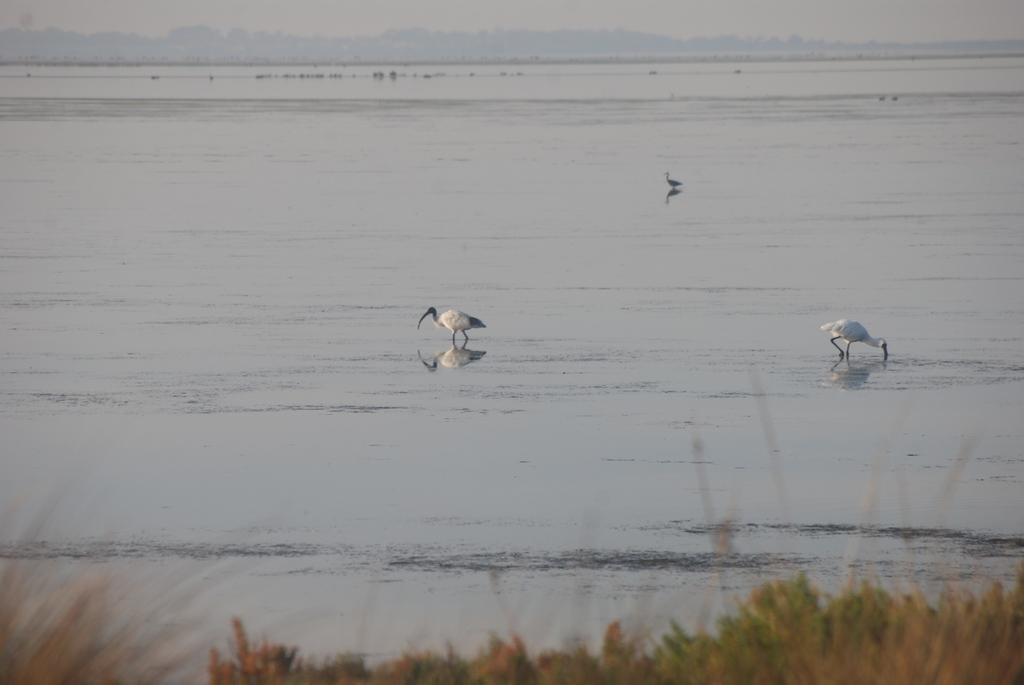What is located in the front of the image? There are plants in the front of the image. What are the birds doing in the image? The birds are standing in the water in the image. What is visible at the top of the image? The sky is visible at the top of the image. Where is the hook located in the image? There is no hook present in the image. What type of car can be seen driving through the water in the image? There is no car present in the image; it features birds standing in the water. Is there a jail visible in the image? There is no jail present in the image. 